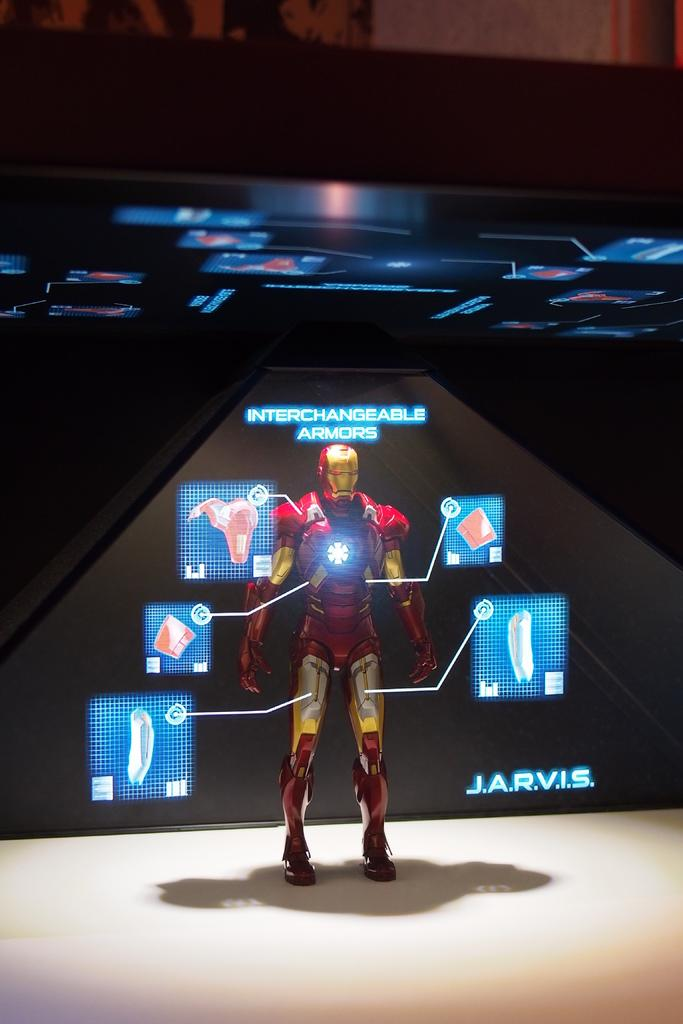<image>
Share a concise interpretation of the image provided. A figure is shown that looks like a human robot, there is INTERCHANGEABLE ARMORS AND J.A.R.V.I.S. written near it. 